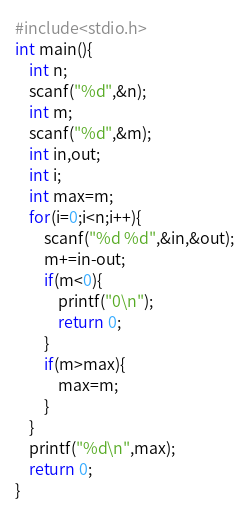Convert code to text. <code><loc_0><loc_0><loc_500><loc_500><_C_>#include<stdio.h>
int main(){
	int n;
	scanf("%d",&n);
	int m;
	scanf("%d",&m);
	int in,out;
	int i;
	int max=m;
	for(i=0;i<n;i++){
		scanf("%d %d",&in,&out);
		m+=in-out;
		if(m<0){
			printf("0\n");
			return 0;
		}
		if(m>max){
			max=m;
		}
	}
	printf("%d\n",max);
	return 0;
}</code> 